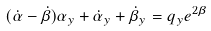<formula> <loc_0><loc_0><loc_500><loc_500>( \dot { \alpha } - \dot { \beta } ) \alpha _ { y } + \dot { \alpha } _ { y } + \dot { \beta } _ { y } = q _ { y } e ^ { 2 \beta }</formula> 